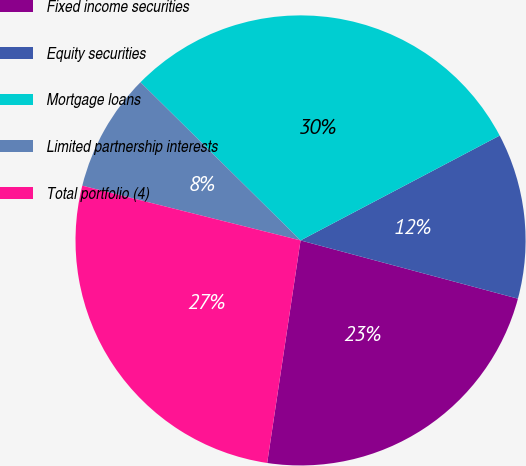Convert chart. <chart><loc_0><loc_0><loc_500><loc_500><pie_chart><fcel>Fixed income securities<fcel>Equity securities<fcel>Mortgage loans<fcel>Limited partnership interests<fcel>Total portfolio (4)<nl><fcel>23.2%<fcel>11.88%<fcel>29.88%<fcel>8.49%<fcel>26.54%<nl></chart> 